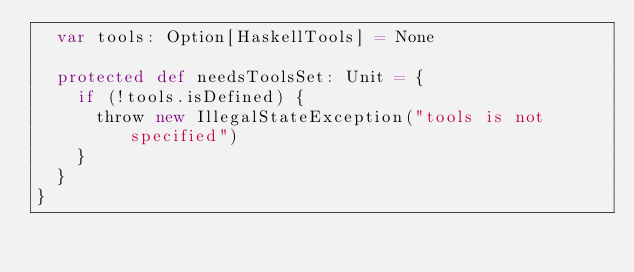Convert code to text. <code><loc_0><loc_0><loc_500><loc_500><_Scala_>  var tools: Option[HaskellTools] = None

  protected def needsToolsSet: Unit = {
    if (!tools.isDefined) {
      throw new IllegalStateException("tools is not specified")
    }
  }
}
</code> 